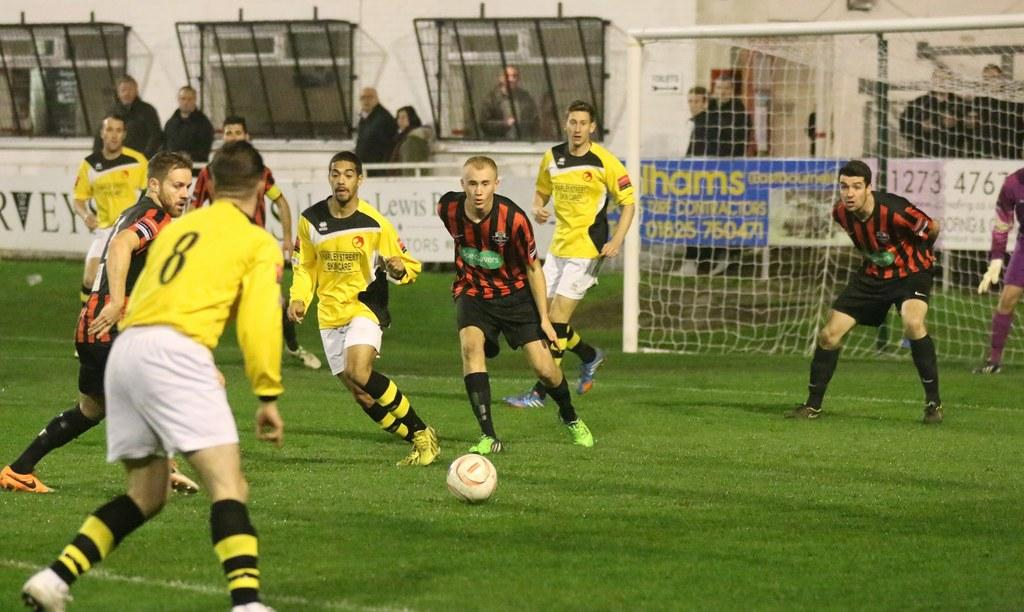<image>
Render a clear and concise summary of the photo. A team in yellow shirts playing soccer, one has 8 on his shirt. 